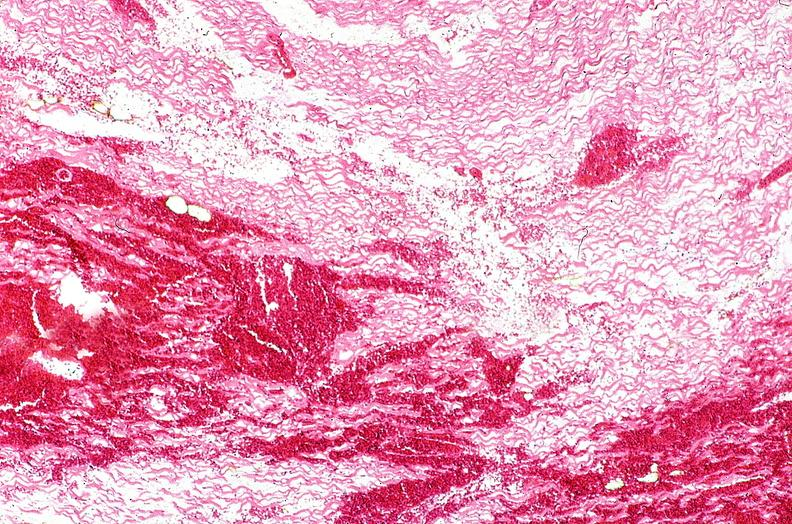what is present?
Answer the question using a single word or phrase. Cardiovascular 